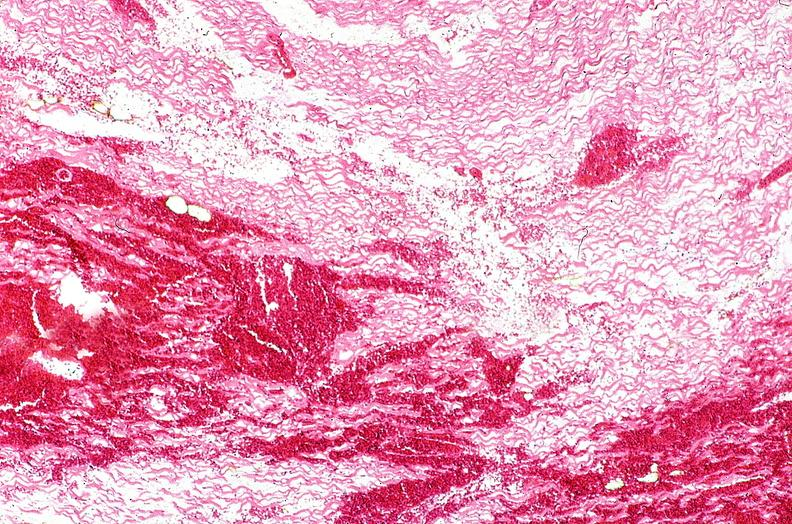what is present?
Answer the question using a single word or phrase. Cardiovascular 